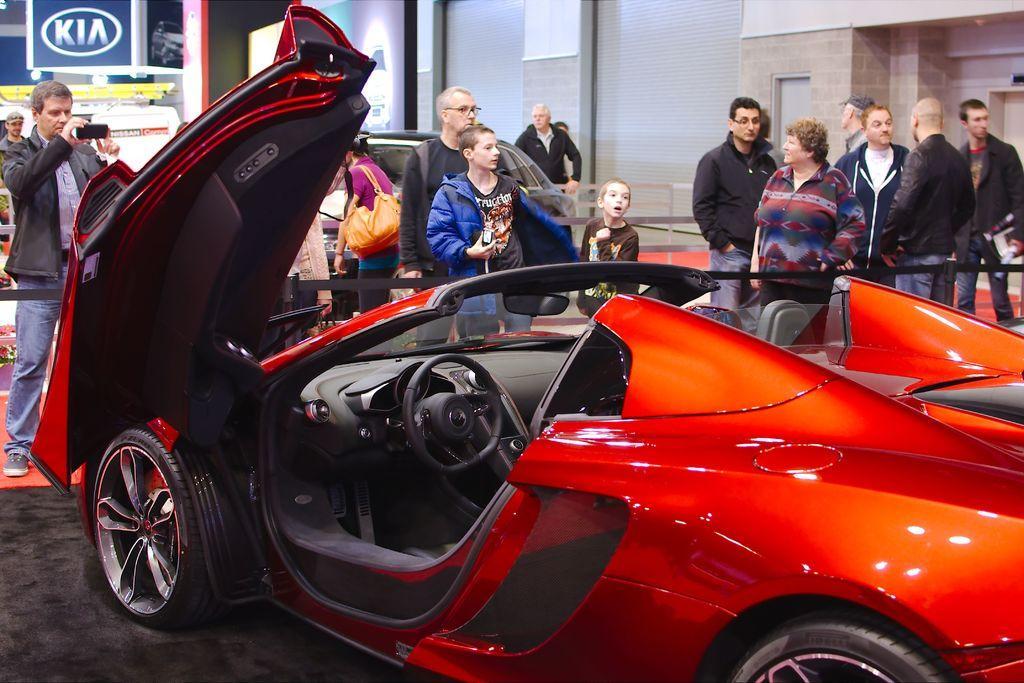Describe this image in one or two sentences. Here, we can see a car, the door of the car is open, we can see a black color steering wheel, there are some people standing, at the left side there is a man standing and he is taking a picture, we can see a KIA sign board. 